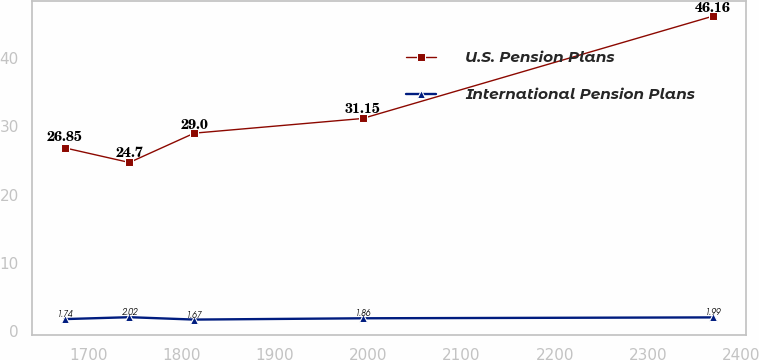Convert chart to OTSL. <chart><loc_0><loc_0><loc_500><loc_500><line_chart><ecel><fcel>U.S. Pension Plans<fcel>International Pension Plans<nl><fcel>1674.5<fcel>26.85<fcel>1.74<nl><fcel>1744.02<fcel>24.7<fcel>2.02<nl><fcel>1813.54<fcel>29<fcel>1.67<nl><fcel>1993.94<fcel>31.15<fcel>1.86<nl><fcel>2369.73<fcel>46.16<fcel>1.99<nl></chart> 